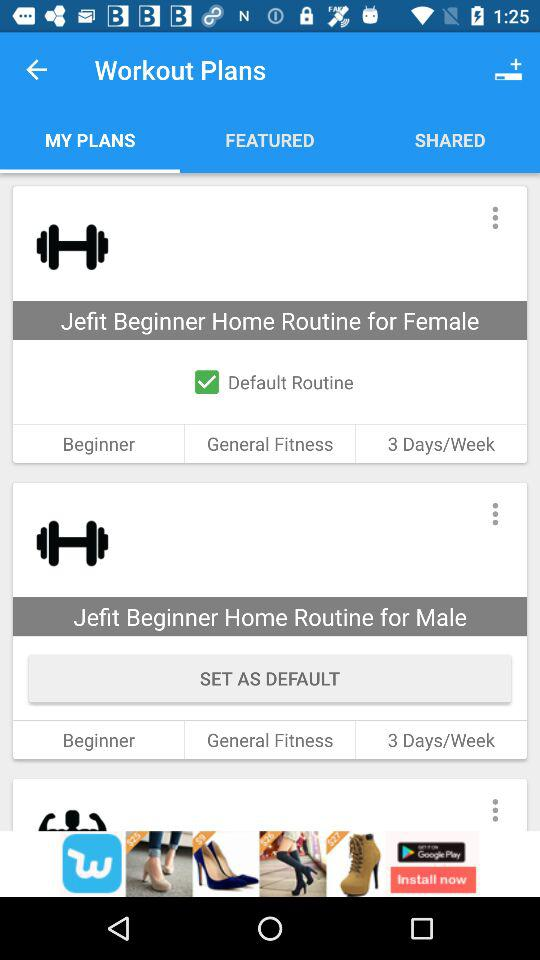What does the Jefit Beginner Home routine comprise of?
When the provided information is insufficient, respond with <no answer>. <no answer> 